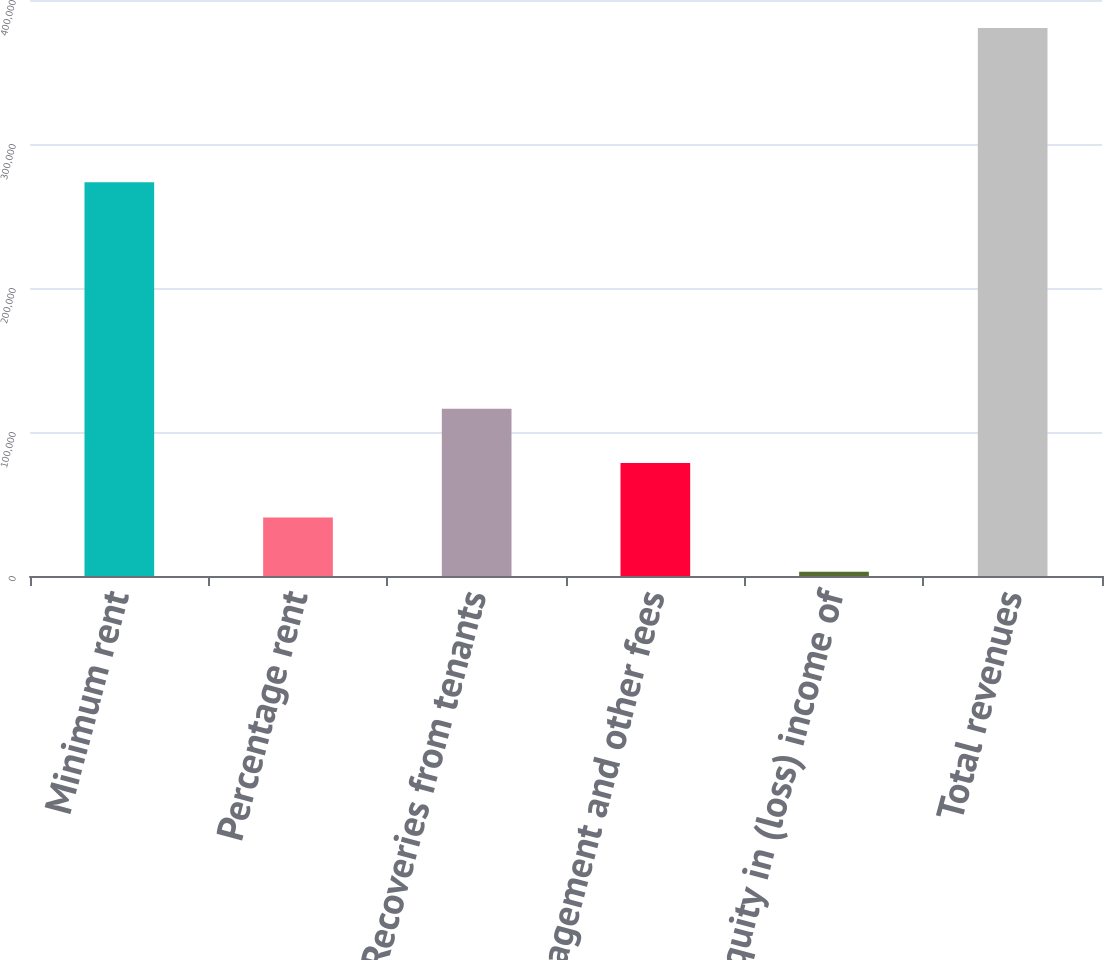Convert chart to OTSL. <chart><loc_0><loc_0><loc_500><loc_500><bar_chart><fcel>Minimum rent<fcel>Percentage rent<fcel>Recoveries from tenants<fcel>Management and other fees<fcel>Equity in (loss) income of<fcel>Total revenues<nl><fcel>273405<fcel>40680.8<fcel>116226<fcel>78453.6<fcel>2908<fcel>380636<nl></chart> 